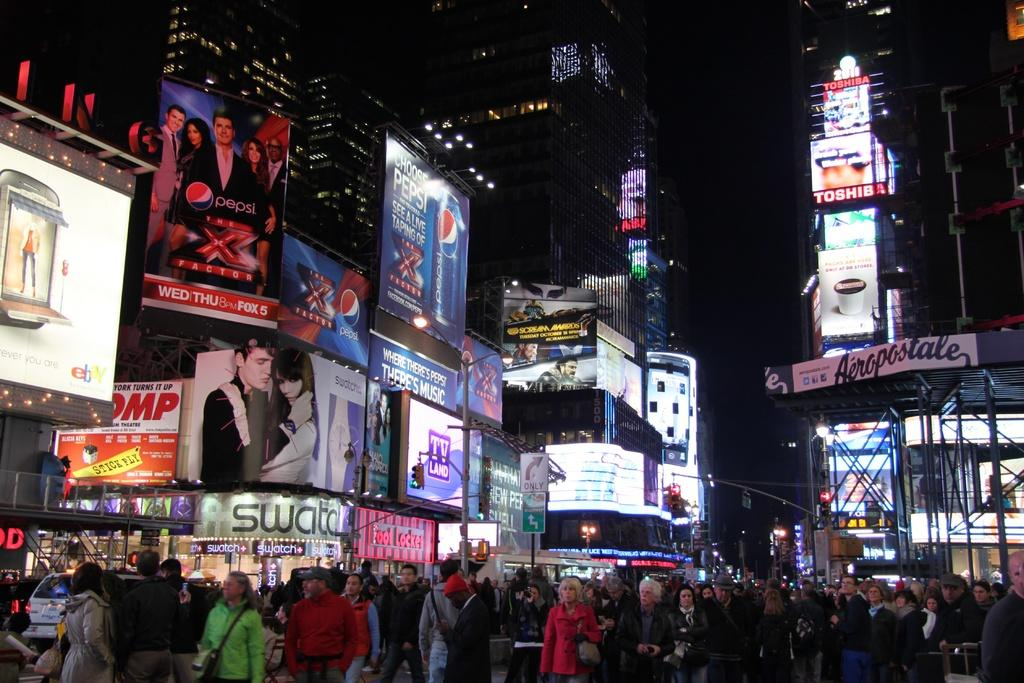Provide a one-sentence caption for the provided image. A billboard that says Choose Pepsi hangs above a very crowded downtown street. 